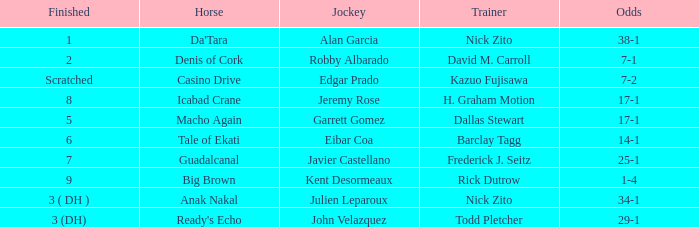Who is the Jockey that has Nick Zito as Trainer and Odds of 34-1? Julien Leparoux. 